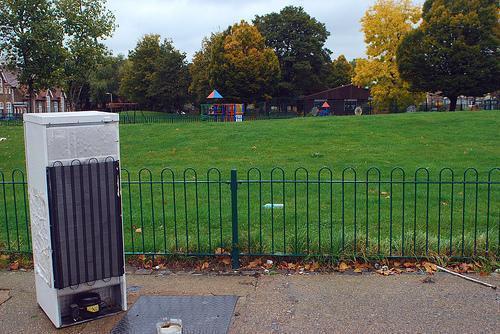How many people are sleeping on the grass?
Give a very brief answer. 0. 